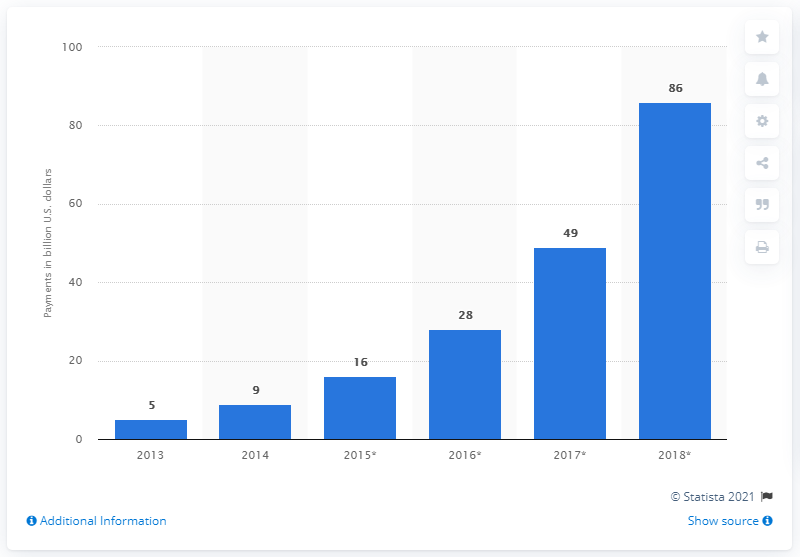Mention a couple of crucial points in this snapshot. The value of mobile P2P payments was predicted to increase significantly to 86% in 2018. In 2015, the value of mobile person-to-person (P2P) payments was 16... 